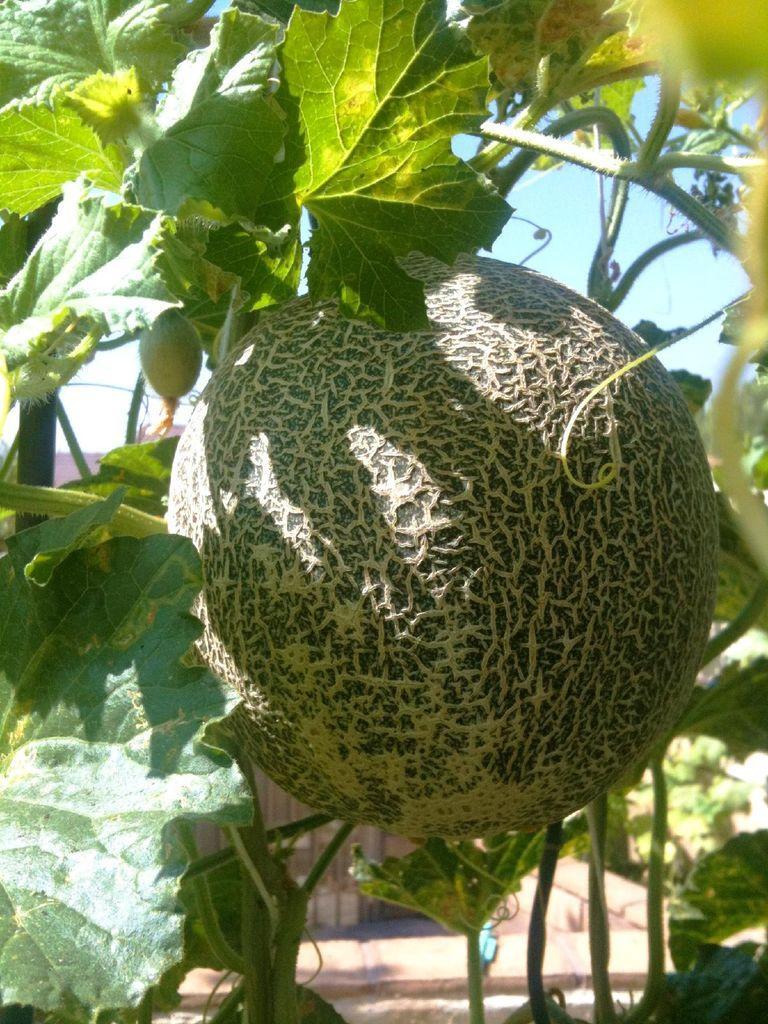Please provide a concise description of this image. In this picture I can see things on a tree. In the background I can see sky. 